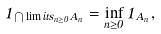Convert formula to latex. <formula><loc_0><loc_0><loc_500><loc_500>1 _ { \bigcap \lim i t s _ { n \geq 0 } A _ { n } } = \inf _ { n \geq 0 } 1 _ { A _ { n } } ,</formula> 